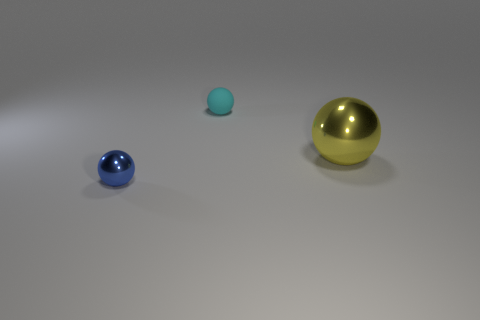Subtract all large balls. How many balls are left? 2 Subtract 2 spheres. How many spheres are left? 1 Add 1 small purple rubber balls. How many objects exist? 4 Subtract all blue balls. How many balls are left? 2 Add 1 cyan rubber things. How many cyan rubber things are left? 2 Add 3 yellow metal balls. How many yellow metal balls exist? 4 Subtract 0 green blocks. How many objects are left? 3 Subtract all gray spheres. Subtract all purple blocks. How many spheres are left? 3 Subtract all purple rubber blocks. Subtract all big balls. How many objects are left? 2 